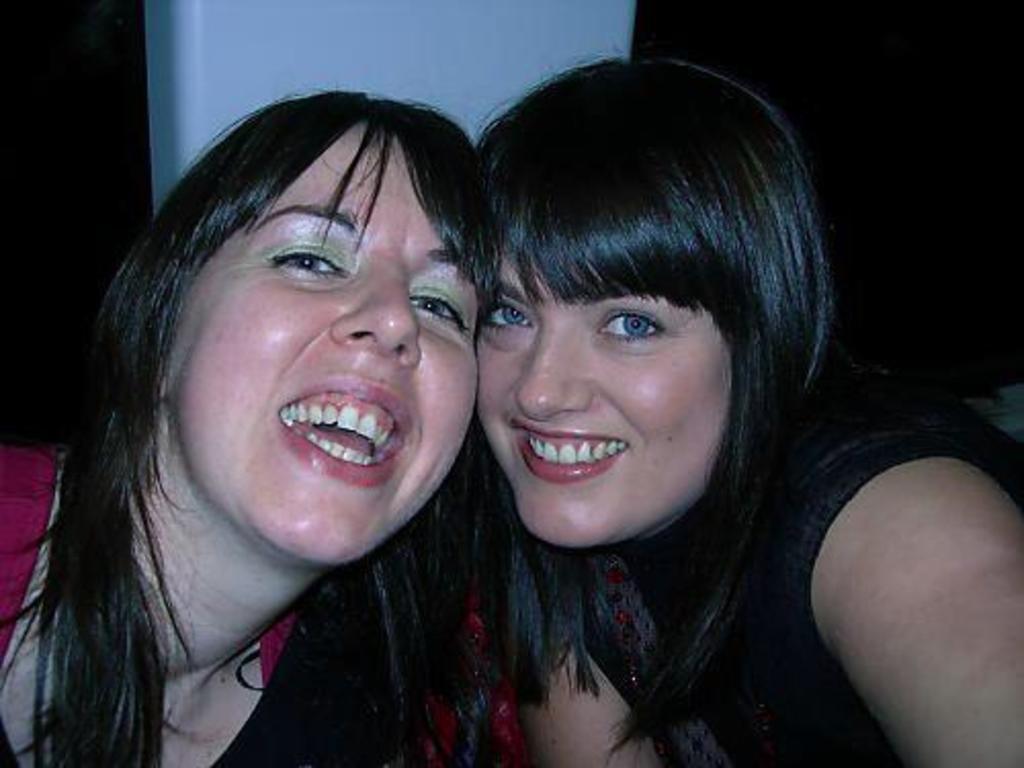Describe this image in one or two sentences. In this image there are two women smiling. There is a dark color background and a white color pillar. 